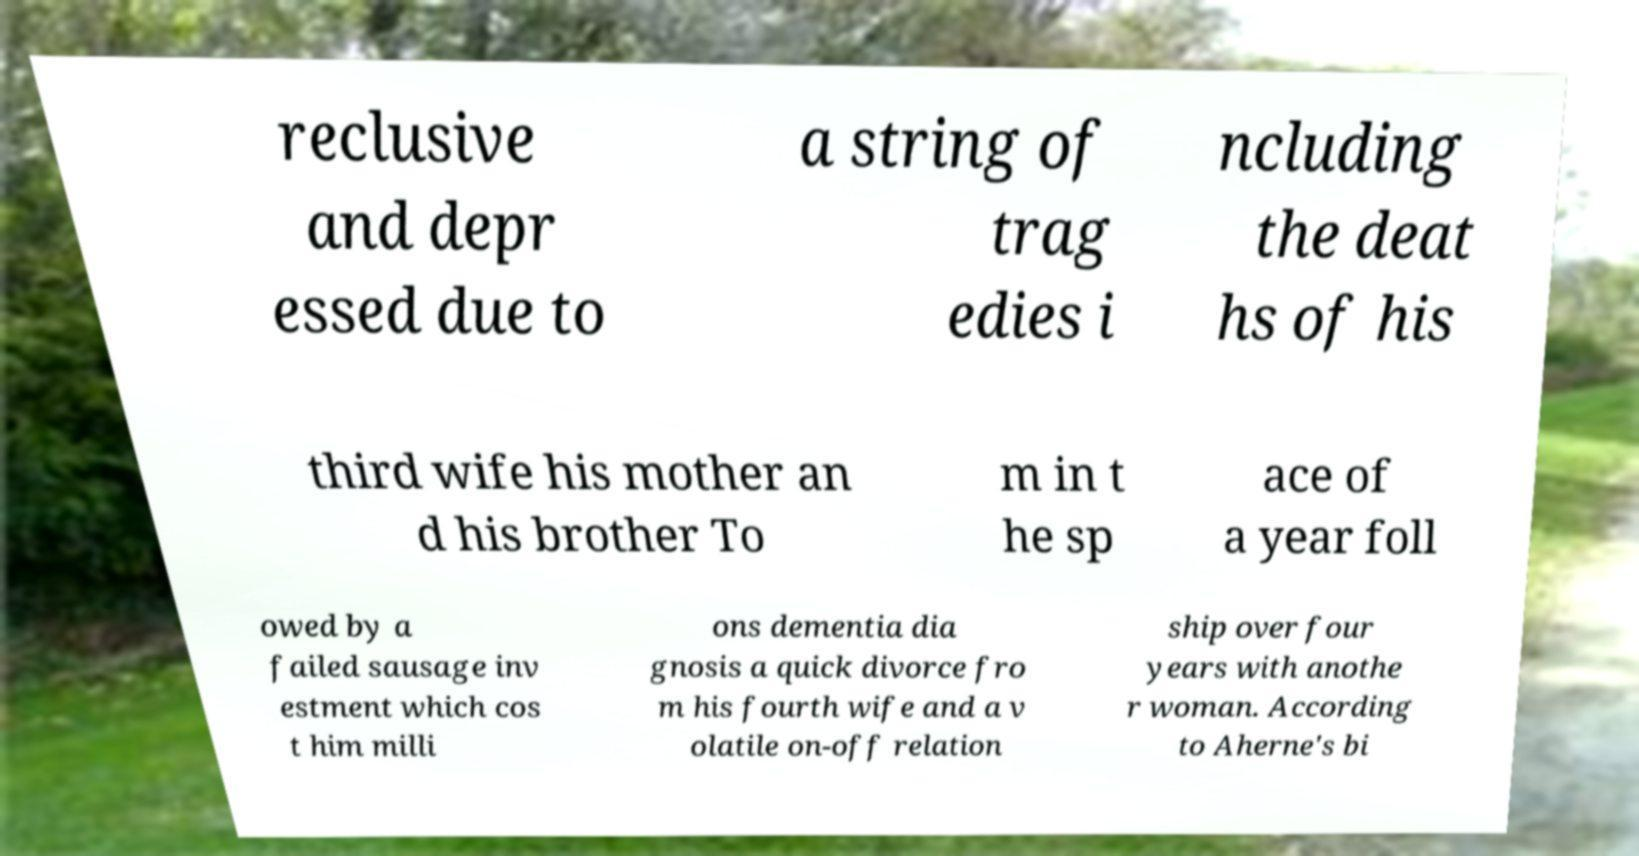There's text embedded in this image that I need extracted. Can you transcribe it verbatim? reclusive and depr essed due to a string of trag edies i ncluding the deat hs of his third wife his mother an d his brother To m in t he sp ace of a year foll owed by a failed sausage inv estment which cos t him milli ons dementia dia gnosis a quick divorce fro m his fourth wife and a v olatile on-off relation ship over four years with anothe r woman. According to Aherne's bi 